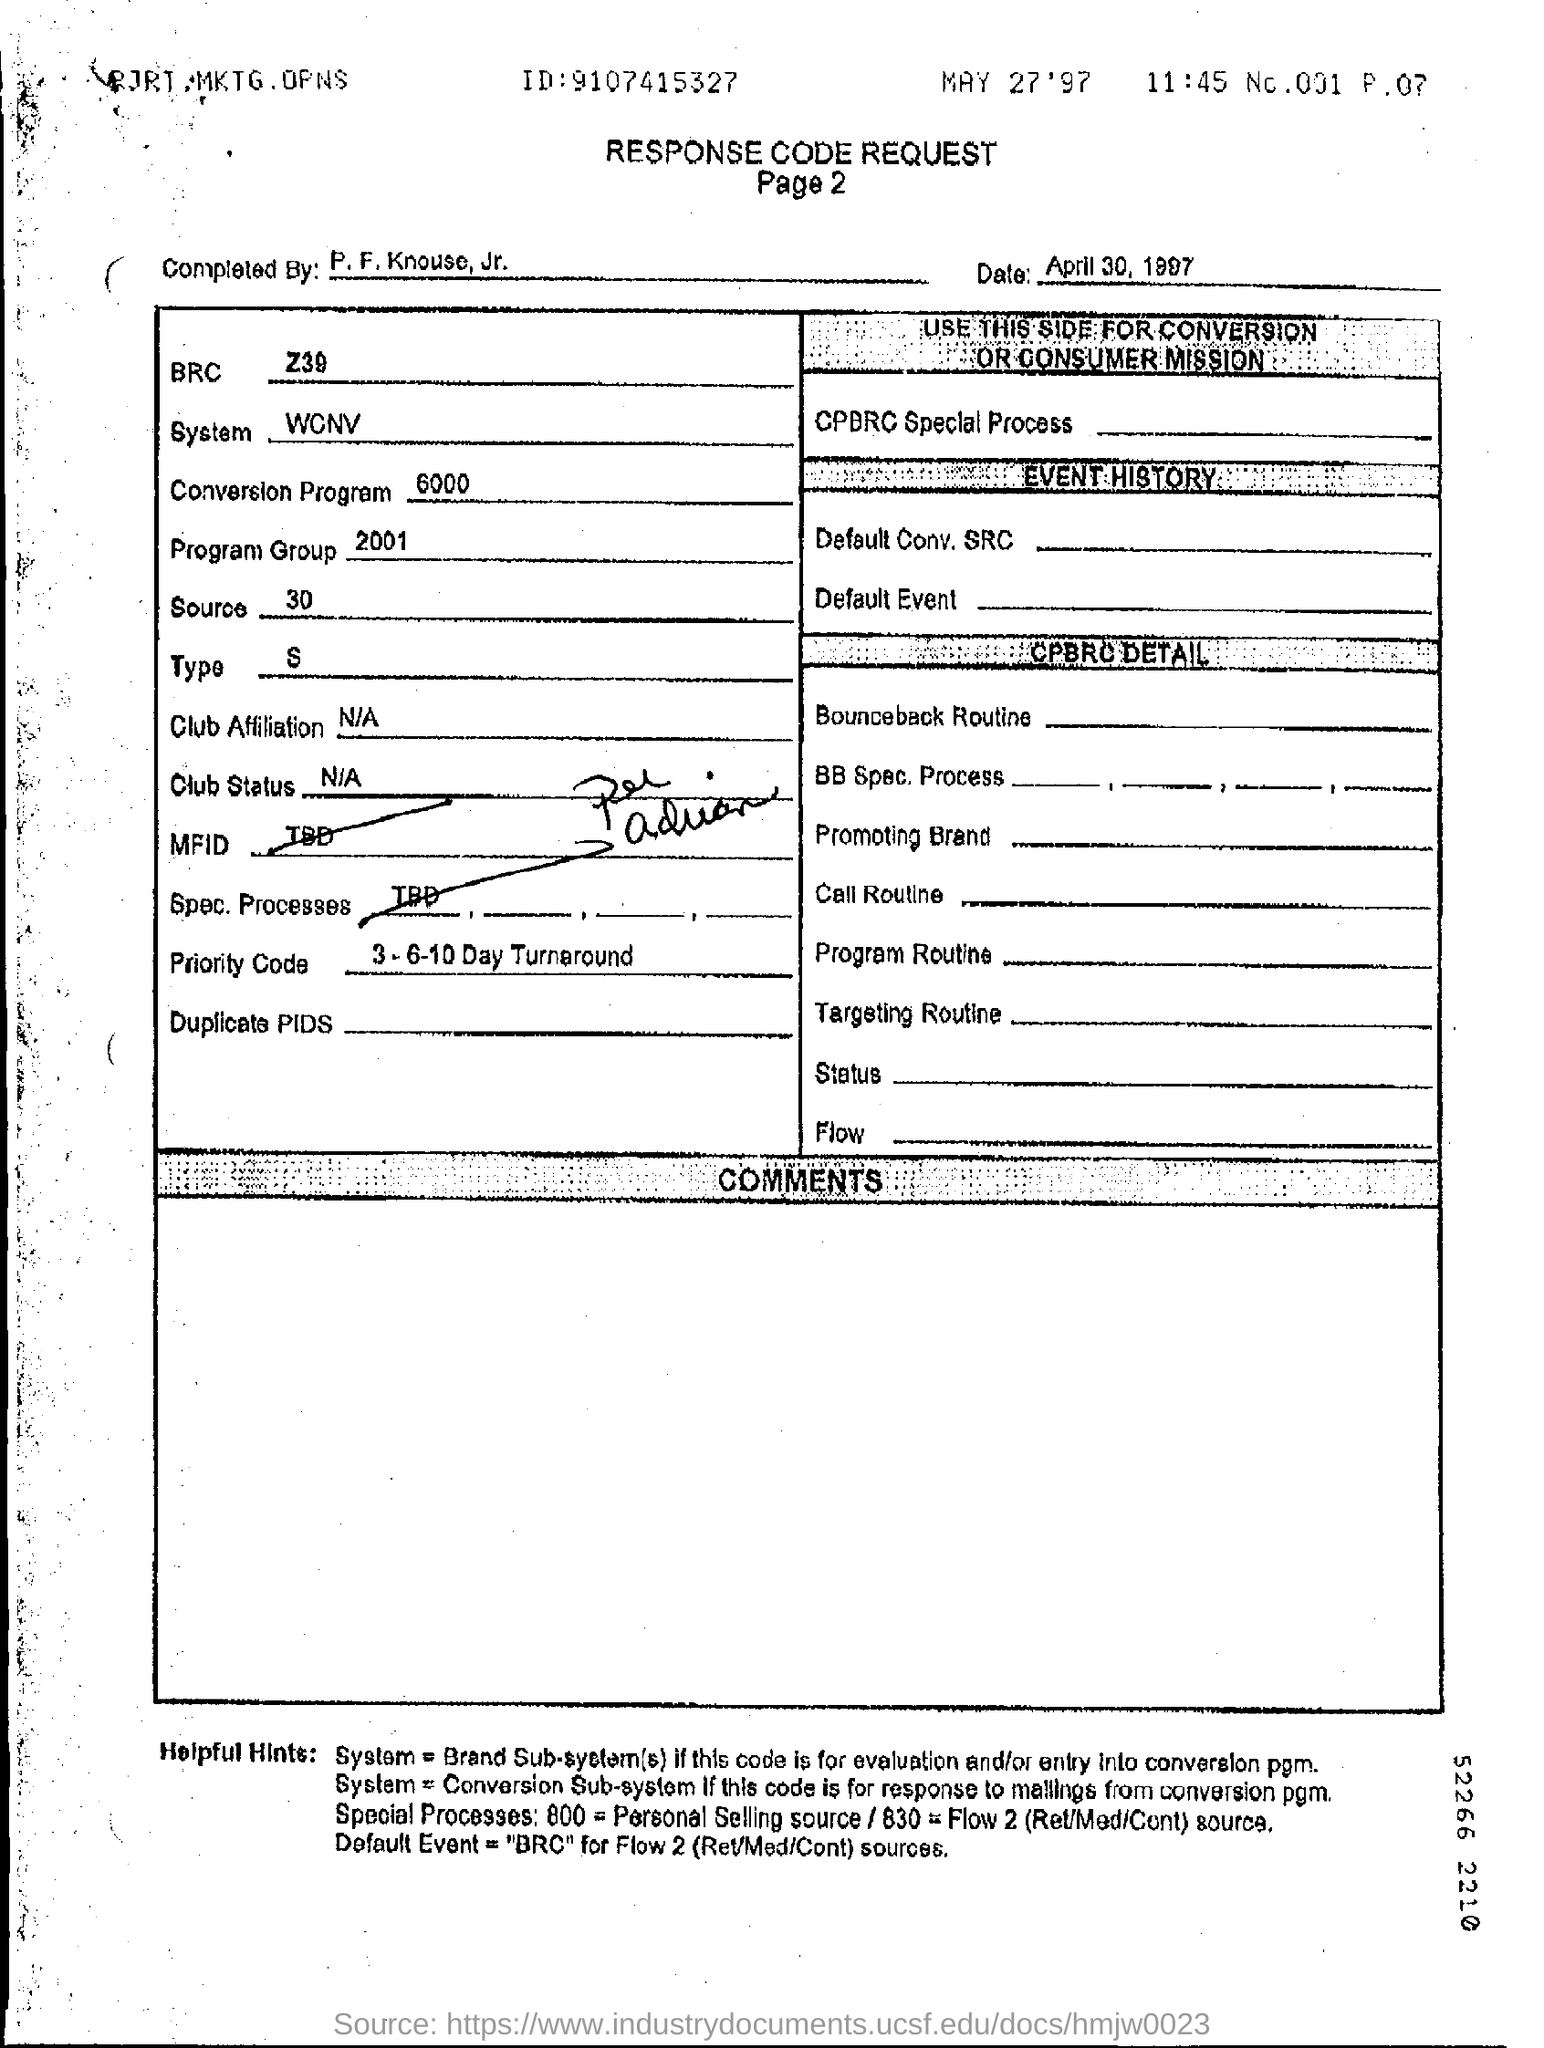Who completed the Response Code Request ?
Make the answer very short. P. F. Knouse, Jr. When was the Response Code request completed ?
Your response must be concise. April 30, 1997. What is the 'BRC' mentioned?
Make the answer very short. Z39. What is the 'Type' mentioned?
Make the answer very short. S. 